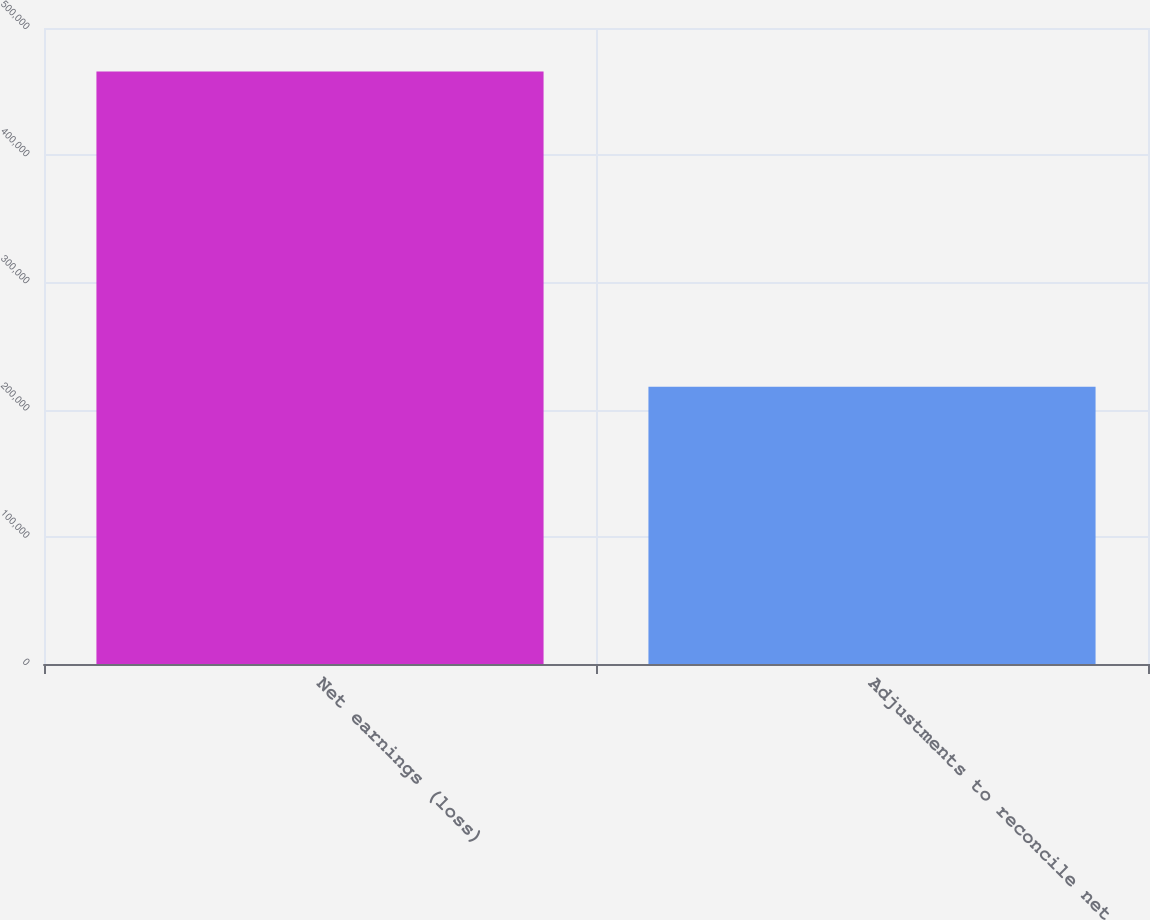Convert chart to OTSL. <chart><loc_0><loc_0><loc_500><loc_500><bar_chart><fcel>Net earnings (loss)<fcel>Adjustments to reconcile net<nl><fcel>465847<fcel>217936<nl></chart> 